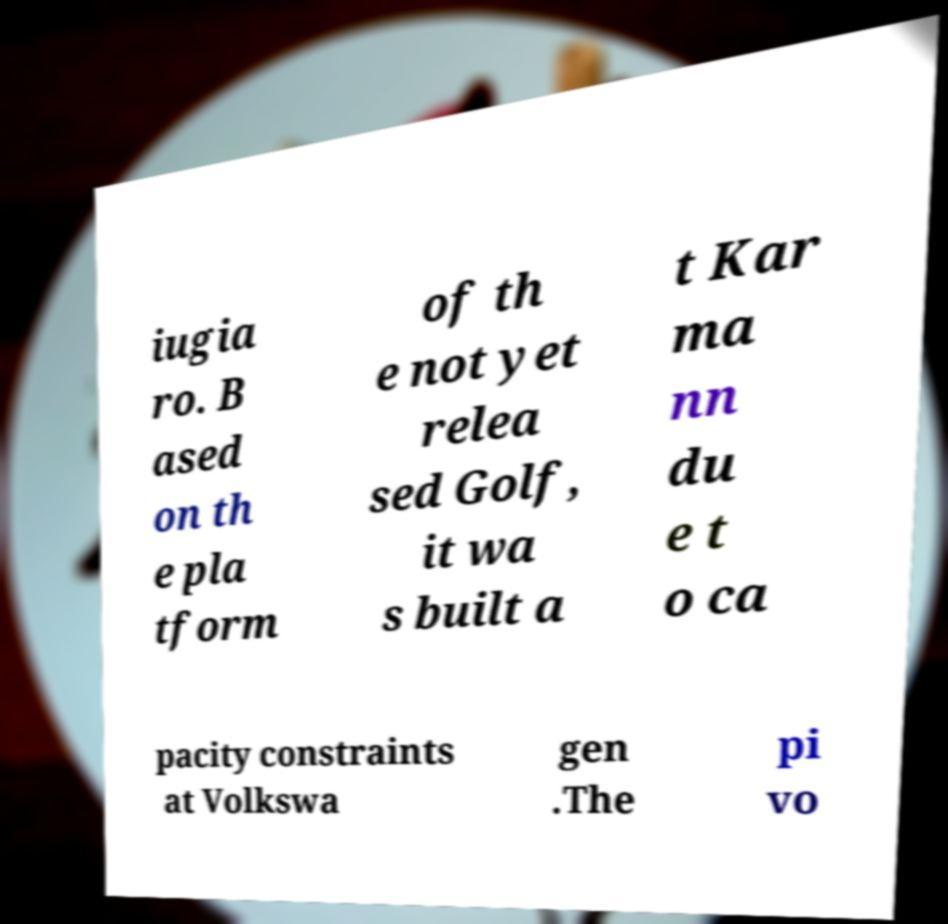There's text embedded in this image that I need extracted. Can you transcribe it verbatim? iugia ro. B ased on th e pla tform of th e not yet relea sed Golf, it wa s built a t Kar ma nn du e t o ca pacity constraints at Volkswa gen .The pi vo 